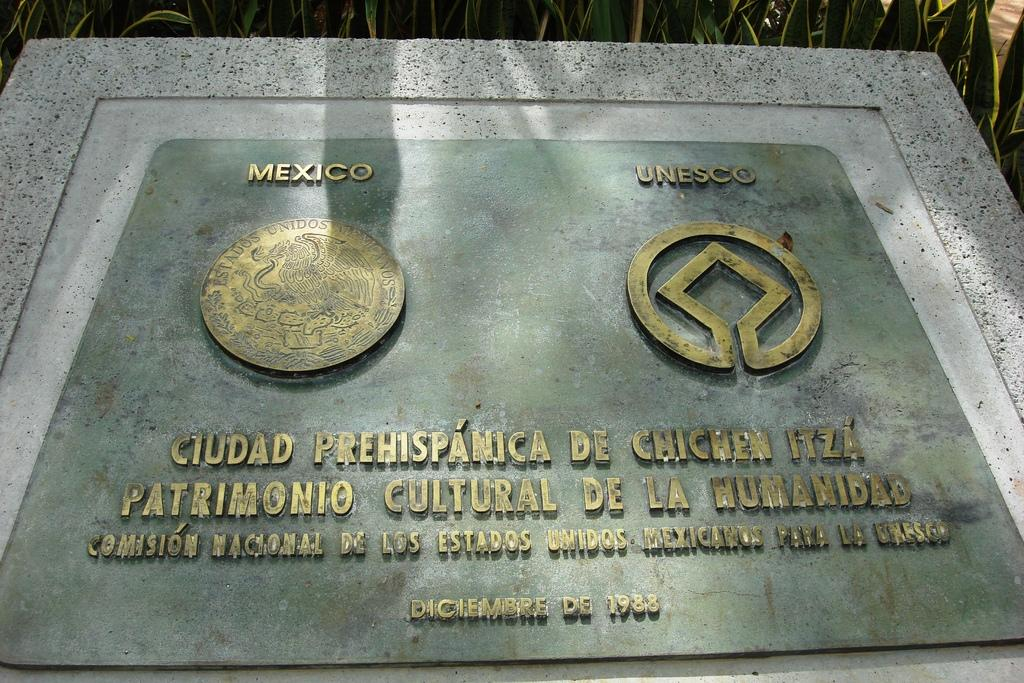<image>
Share a concise interpretation of the image provided. A plaque featuring logos of Mexico and Unesco. 